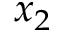Convert formula to latex. <formula><loc_0><loc_0><loc_500><loc_500>x _ { 2 }</formula> 